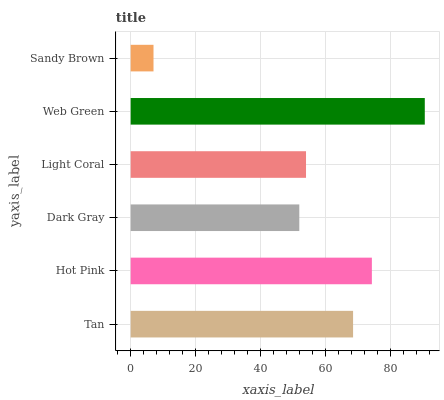Is Sandy Brown the minimum?
Answer yes or no. Yes. Is Web Green the maximum?
Answer yes or no. Yes. Is Hot Pink the minimum?
Answer yes or no. No. Is Hot Pink the maximum?
Answer yes or no. No. Is Hot Pink greater than Tan?
Answer yes or no. Yes. Is Tan less than Hot Pink?
Answer yes or no. Yes. Is Tan greater than Hot Pink?
Answer yes or no. No. Is Hot Pink less than Tan?
Answer yes or no. No. Is Tan the high median?
Answer yes or no. Yes. Is Light Coral the low median?
Answer yes or no. Yes. Is Web Green the high median?
Answer yes or no. No. Is Hot Pink the low median?
Answer yes or no. No. 